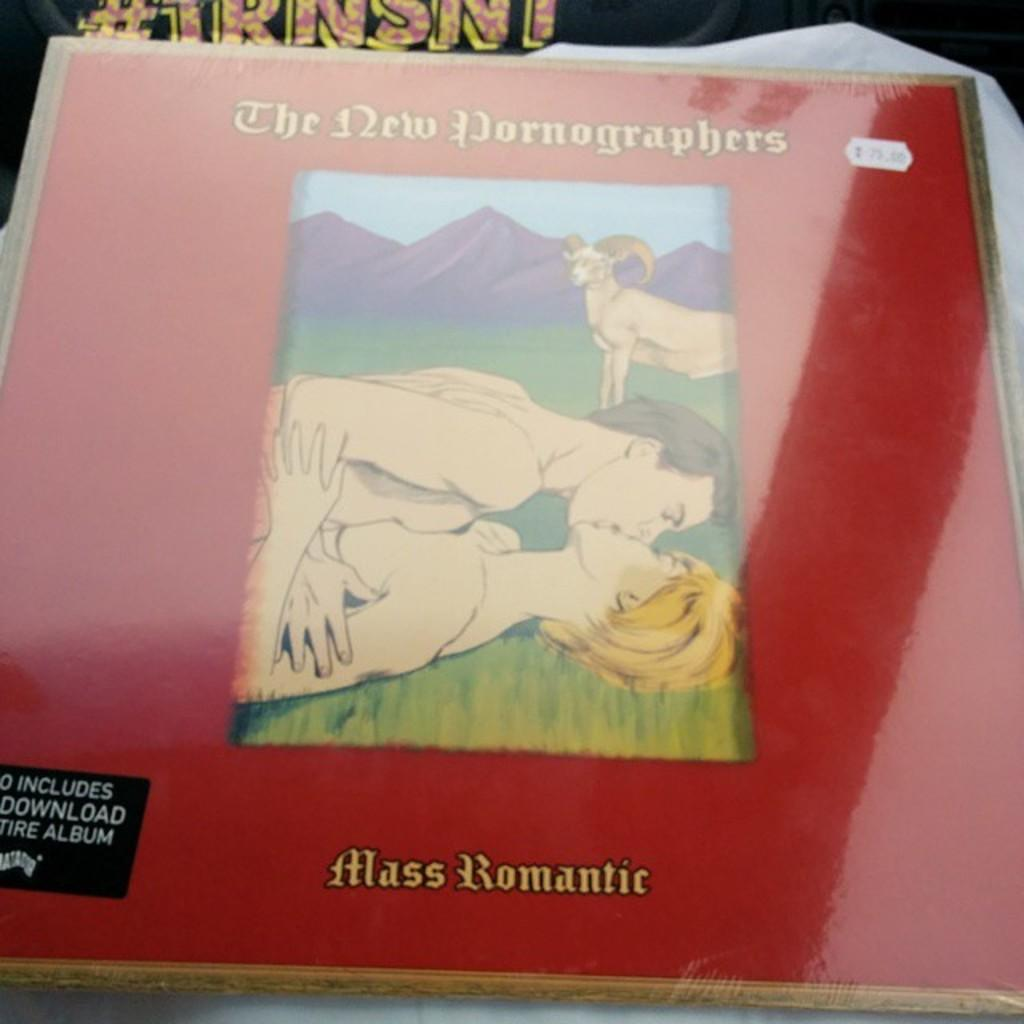What is the main object in the image? There is a book in the image. What type of content does the book have? The book contains pictures and text. Where is the book located in the image? The book is placed on a surface. What type of ornament is hanging from the book in the image? There is no ornament hanging from the book in the image. Can you tell me how many lettuce leaves are on the book in the image? There is no lettuce present in the image. 